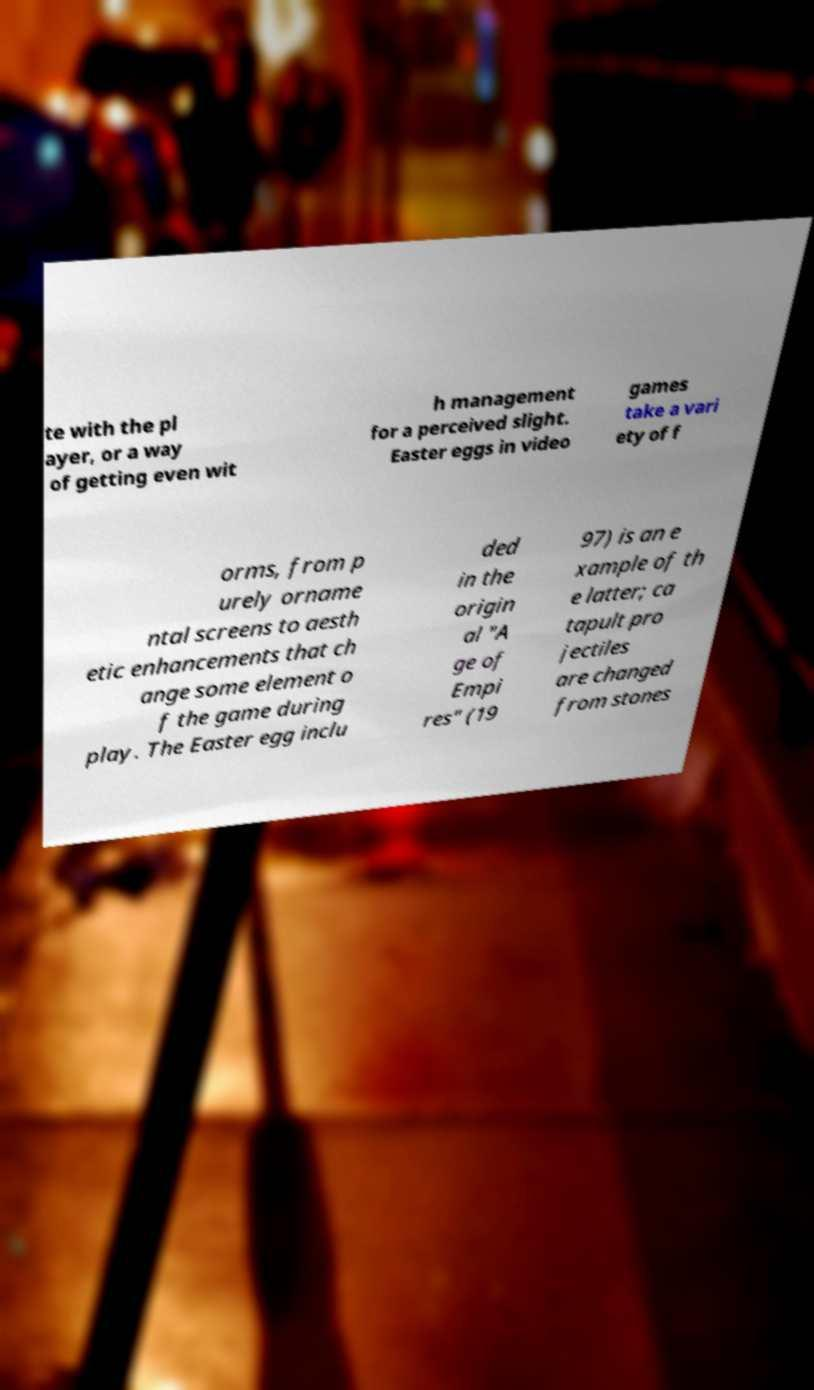What messages or text are displayed in this image? I need them in a readable, typed format. te with the pl ayer, or a way of getting even wit h management for a perceived slight. Easter eggs in video games take a vari ety of f orms, from p urely orname ntal screens to aesth etic enhancements that ch ange some element o f the game during play. The Easter egg inclu ded in the origin al "A ge of Empi res" (19 97) is an e xample of th e latter; ca tapult pro jectiles are changed from stones 